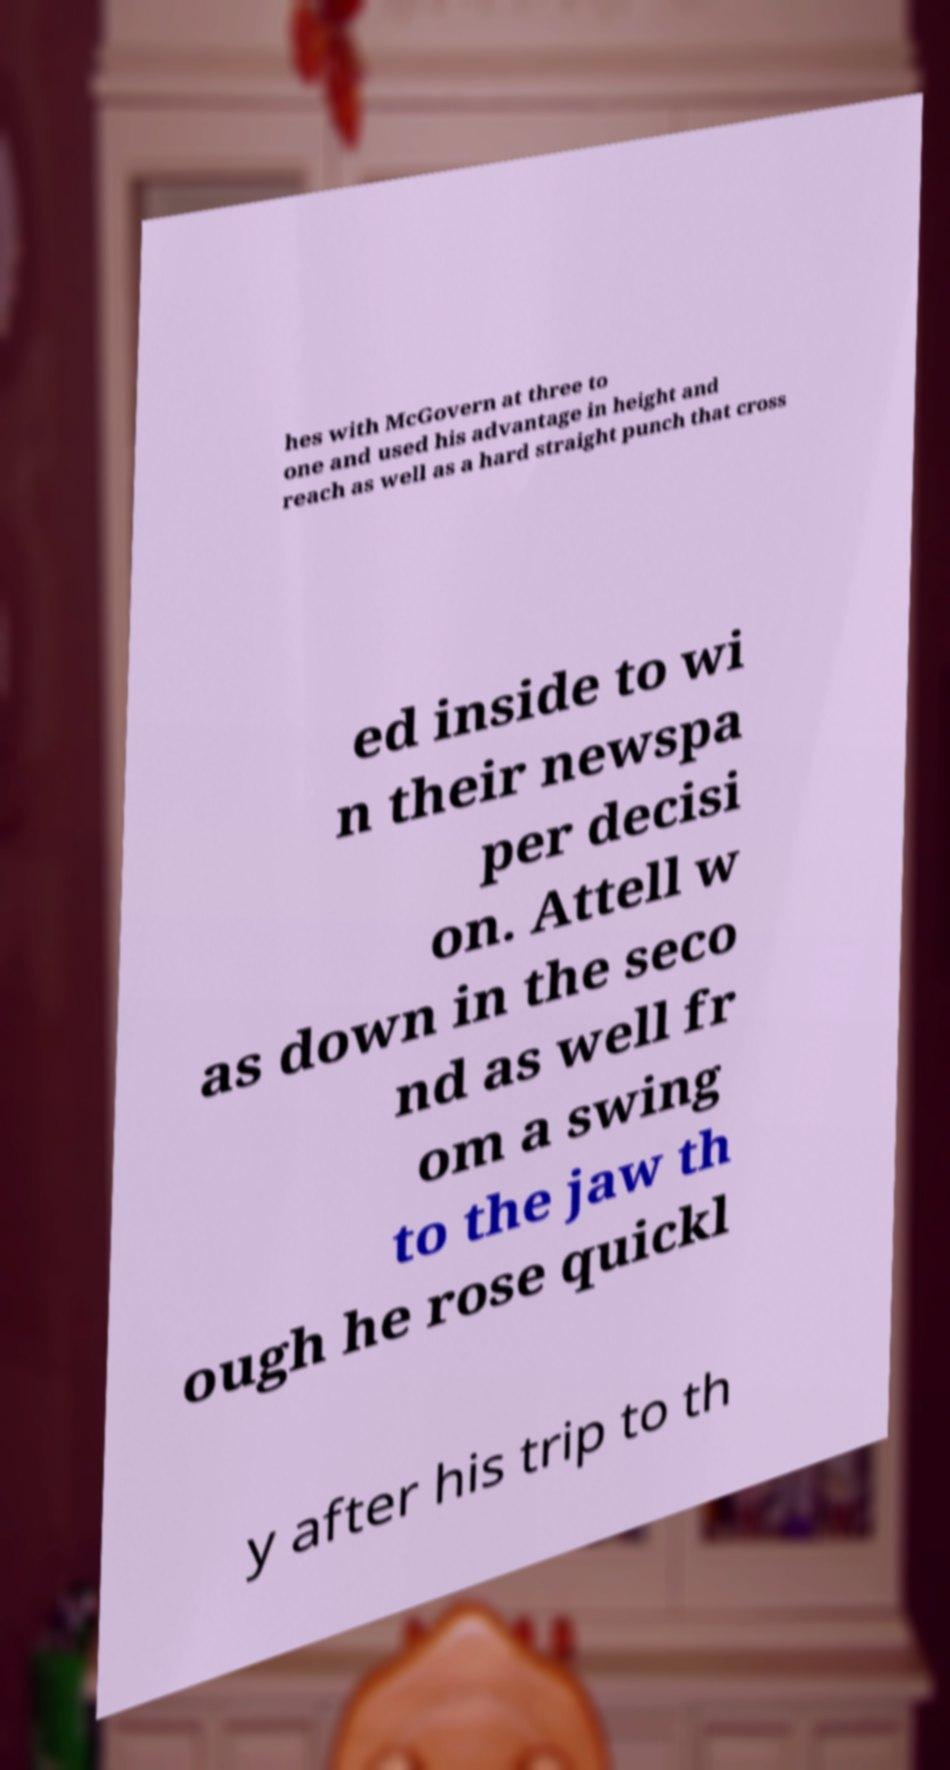What messages or text are displayed in this image? I need them in a readable, typed format. hes with McGovern at three to one and used his advantage in height and reach as well as a hard straight punch that cross ed inside to wi n their newspa per decisi on. Attell w as down in the seco nd as well fr om a swing to the jaw th ough he rose quickl y after his trip to th 